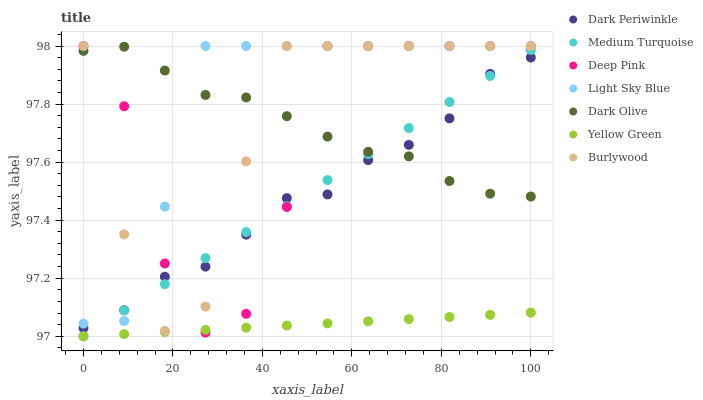Does Yellow Green have the minimum area under the curve?
Answer yes or no. Yes. Does Light Sky Blue have the maximum area under the curve?
Answer yes or no. Yes. Does Burlywood have the minimum area under the curve?
Answer yes or no. No. Does Burlywood have the maximum area under the curve?
Answer yes or no. No. Is Medium Turquoise the smoothest?
Answer yes or no. Yes. Is Deep Pink the roughest?
Answer yes or no. Yes. Is Yellow Green the smoothest?
Answer yes or no. No. Is Yellow Green the roughest?
Answer yes or no. No. Does Yellow Green have the lowest value?
Answer yes or no. Yes. Does Burlywood have the lowest value?
Answer yes or no. No. Does Light Sky Blue have the highest value?
Answer yes or no. Yes. Does Yellow Green have the highest value?
Answer yes or no. No. Is Yellow Green less than Dark Periwinkle?
Answer yes or no. Yes. Is Light Sky Blue greater than Yellow Green?
Answer yes or no. Yes. Does Deep Pink intersect Burlywood?
Answer yes or no. Yes. Is Deep Pink less than Burlywood?
Answer yes or no. No. Is Deep Pink greater than Burlywood?
Answer yes or no. No. Does Yellow Green intersect Dark Periwinkle?
Answer yes or no. No. 